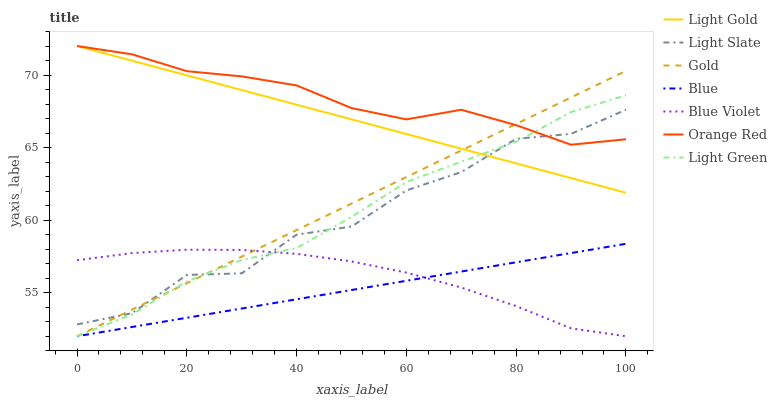Does Blue have the minimum area under the curve?
Answer yes or no. Yes. Does Orange Red have the maximum area under the curve?
Answer yes or no. Yes. Does Gold have the minimum area under the curve?
Answer yes or no. No. Does Gold have the maximum area under the curve?
Answer yes or no. No. Is Blue the smoothest?
Answer yes or no. Yes. Is Light Slate the roughest?
Answer yes or no. Yes. Is Gold the smoothest?
Answer yes or no. No. Is Gold the roughest?
Answer yes or no. No. Does Blue have the lowest value?
Answer yes or no. Yes. Does Light Slate have the lowest value?
Answer yes or no. No. Does Orange Red have the highest value?
Answer yes or no. Yes. Does Gold have the highest value?
Answer yes or no. No. Is Blue less than Orange Red?
Answer yes or no. Yes. Is Light Slate greater than Blue?
Answer yes or no. Yes. Does Gold intersect Light Gold?
Answer yes or no. Yes. Is Gold less than Light Gold?
Answer yes or no. No. Is Gold greater than Light Gold?
Answer yes or no. No. Does Blue intersect Orange Red?
Answer yes or no. No. 